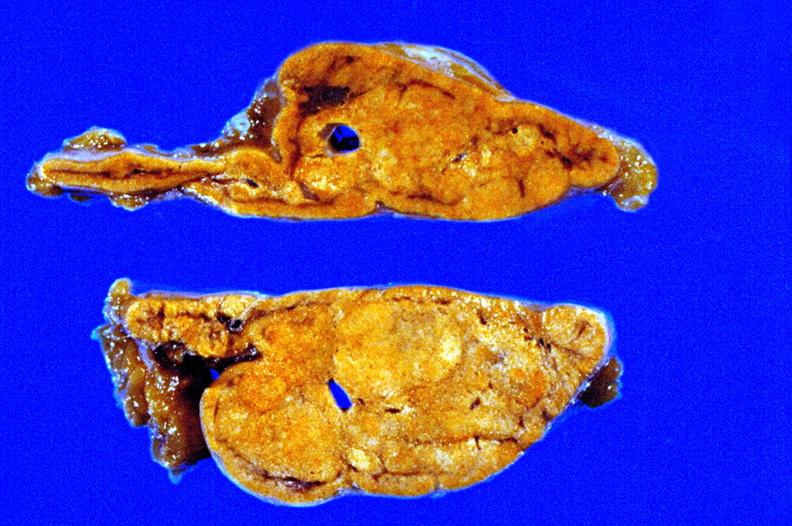what cut surface close-up view rather good apparently non-functional?
Answer the question using a single word or phrase. Fixed tissue 